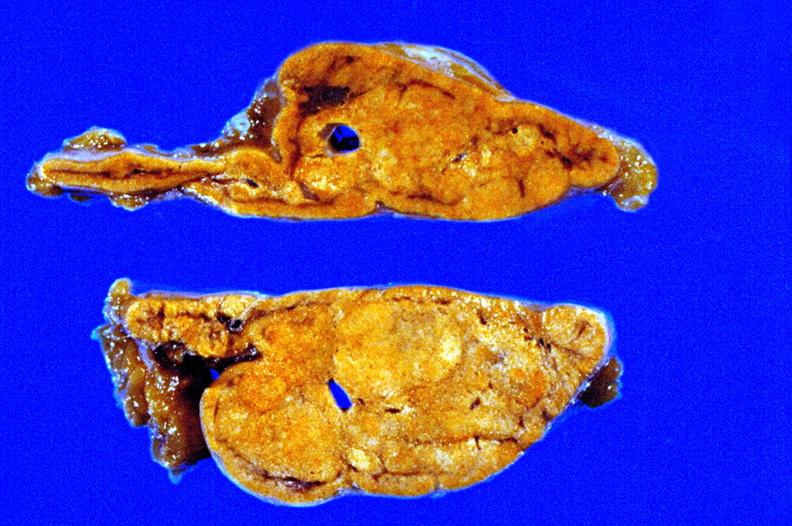what cut surface close-up view rather good apparently non-functional?
Answer the question using a single word or phrase. Fixed tissue 